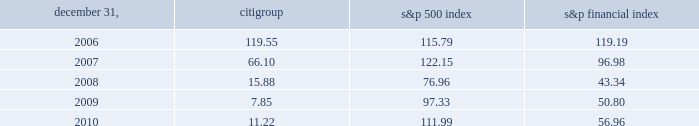Dividends for a summary of the cash dividends paid on citi 2019s outstanding common stock during 2009 and 2010 , see note 33 to the consolidated financial statements .
For so long as the u.s .
Government holds any citigroup trust preferred securities acquired pursuant to the exchange offers consummated in 2009 , citigroup has agreed not to pay a quarterly common stock dividend exceeding $ 0.01 per quarter , subject to certain customary exceptions .
Further , any dividend on citi 2019s outstanding common stock would need to be made in compliance with citi 2019s obligations to any remaining outstanding citigroup preferred stock .
Performance graph comparison of five-year cumulative total return the following graph and table compare the cumulative total return on citigroup 2019s common stock with the cumulative total return of the s&p 500 index and the s&p financial index over the five-year period extending through december 31 , 2010 .
The graph and table assume that $ 100 was invested on december 31 , 2005 in citigroup 2019s common stock , the s&p 500 index and the s&p financial index and that all dividends were reinvested .
Citigroup s&p 500 index s&p financial index comparison of five-year cumulative total return for the years ended 2006 2007 2008 2009 2010 .

What was the percentage cumulative total return for cititgroup's common stock for the five year period ending 2010? 
Computations: ((11.22 - 100) / 100)
Answer: -0.8878. 